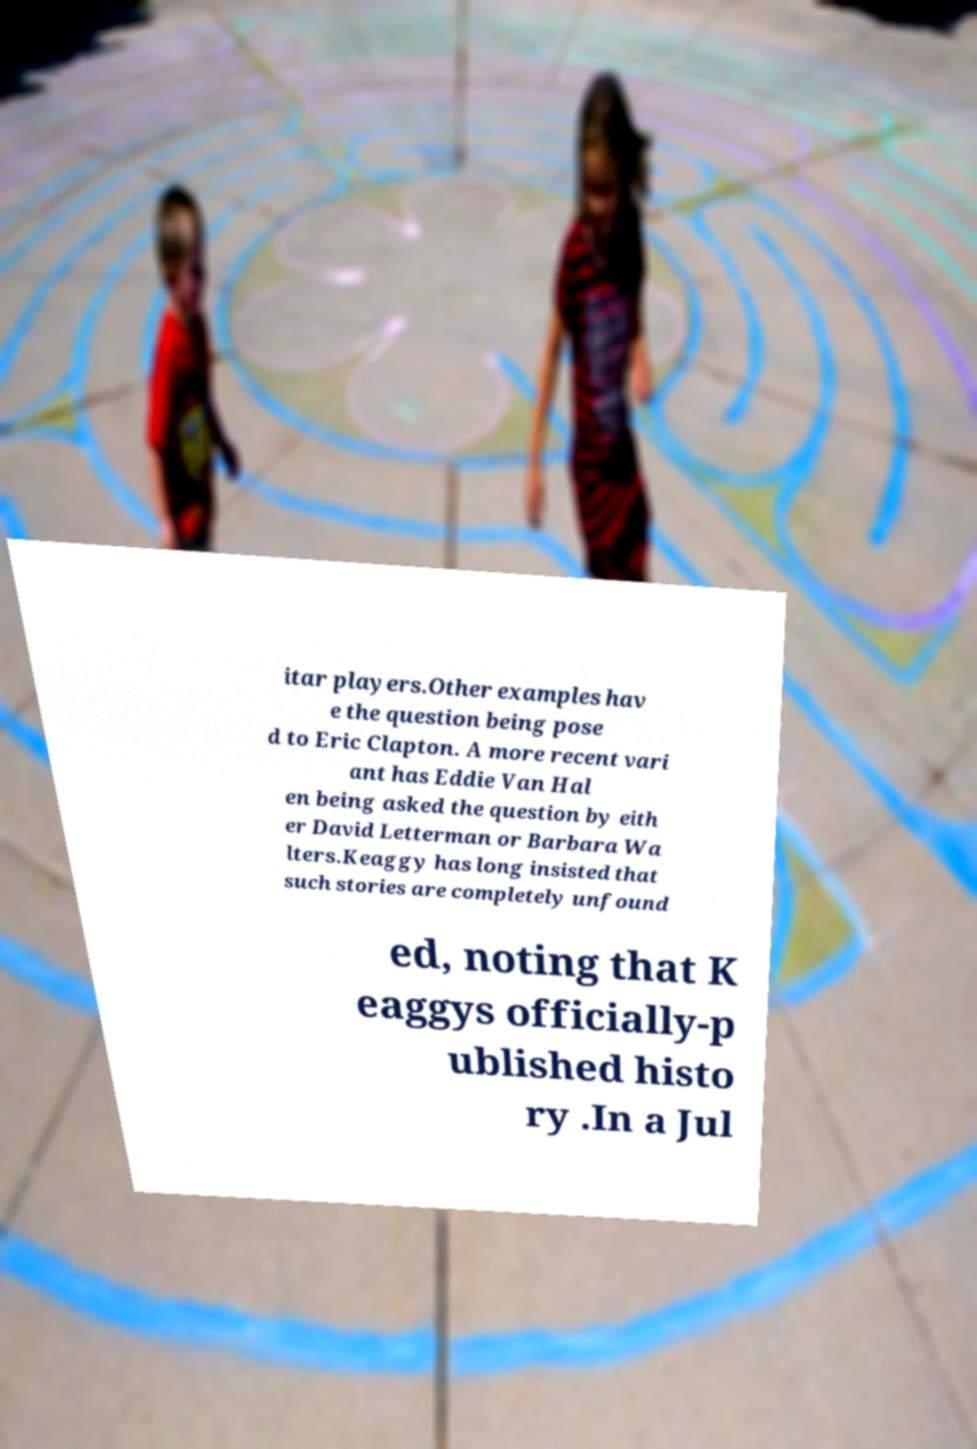I need the written content from this picture converted into text. Can you do that? itar players.Other examples hav e the question being pose d to Eric Clapton. A more recent vari ant has Eddie Van Hal en being asked the question by eith er David Letterman or Barbara Wa lters.Keaggy has long insisted that such stories are completely unfound ed, noting that K eaggys officially-p ublished histo ry .In a Jul 